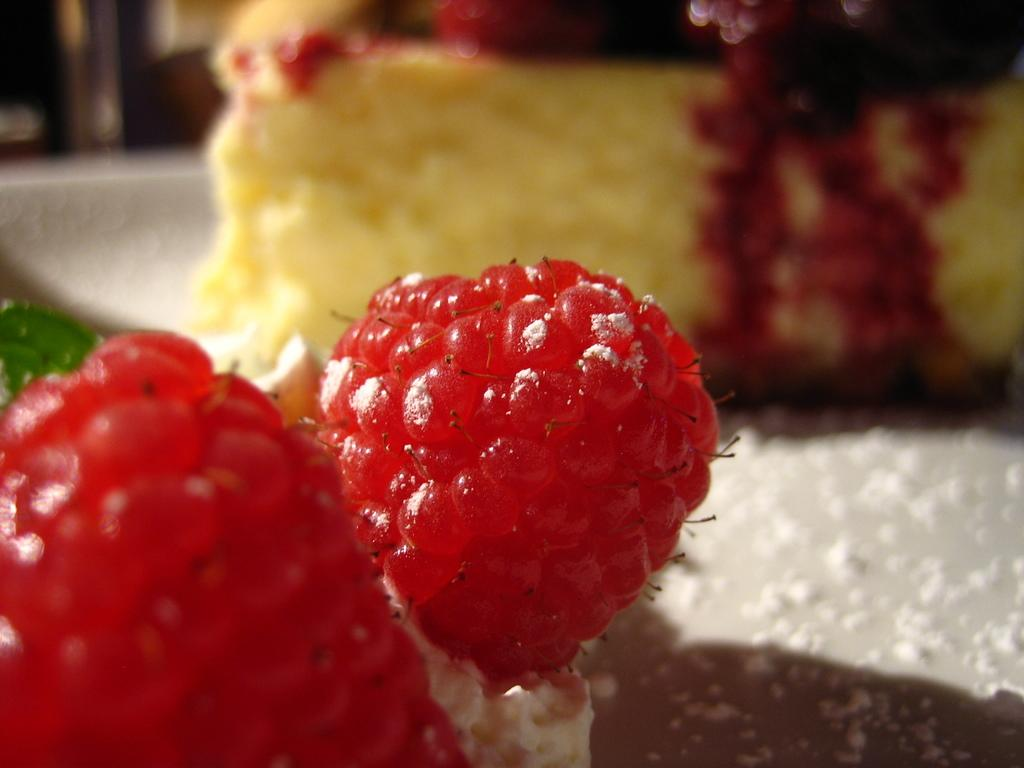What type of fruit is in the picture? There is a berry in the picture. What dessert is also present in the image? There is a cake in the picture. What type of ear is visible in the picture? There is no ear present in the image; it features a berry and a cake. How many umbrellas are used as toppings on the cake in the picture? There are no umbrellas present in the image, as it only features a berry and a cake. 